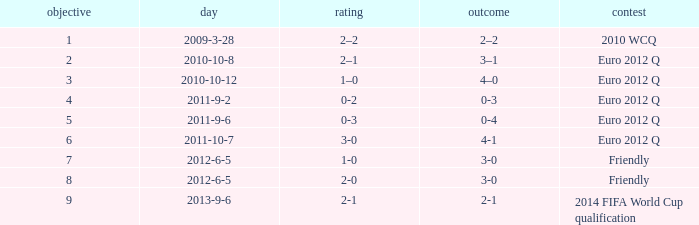What is the result when the score is 0-2? 0-3. 